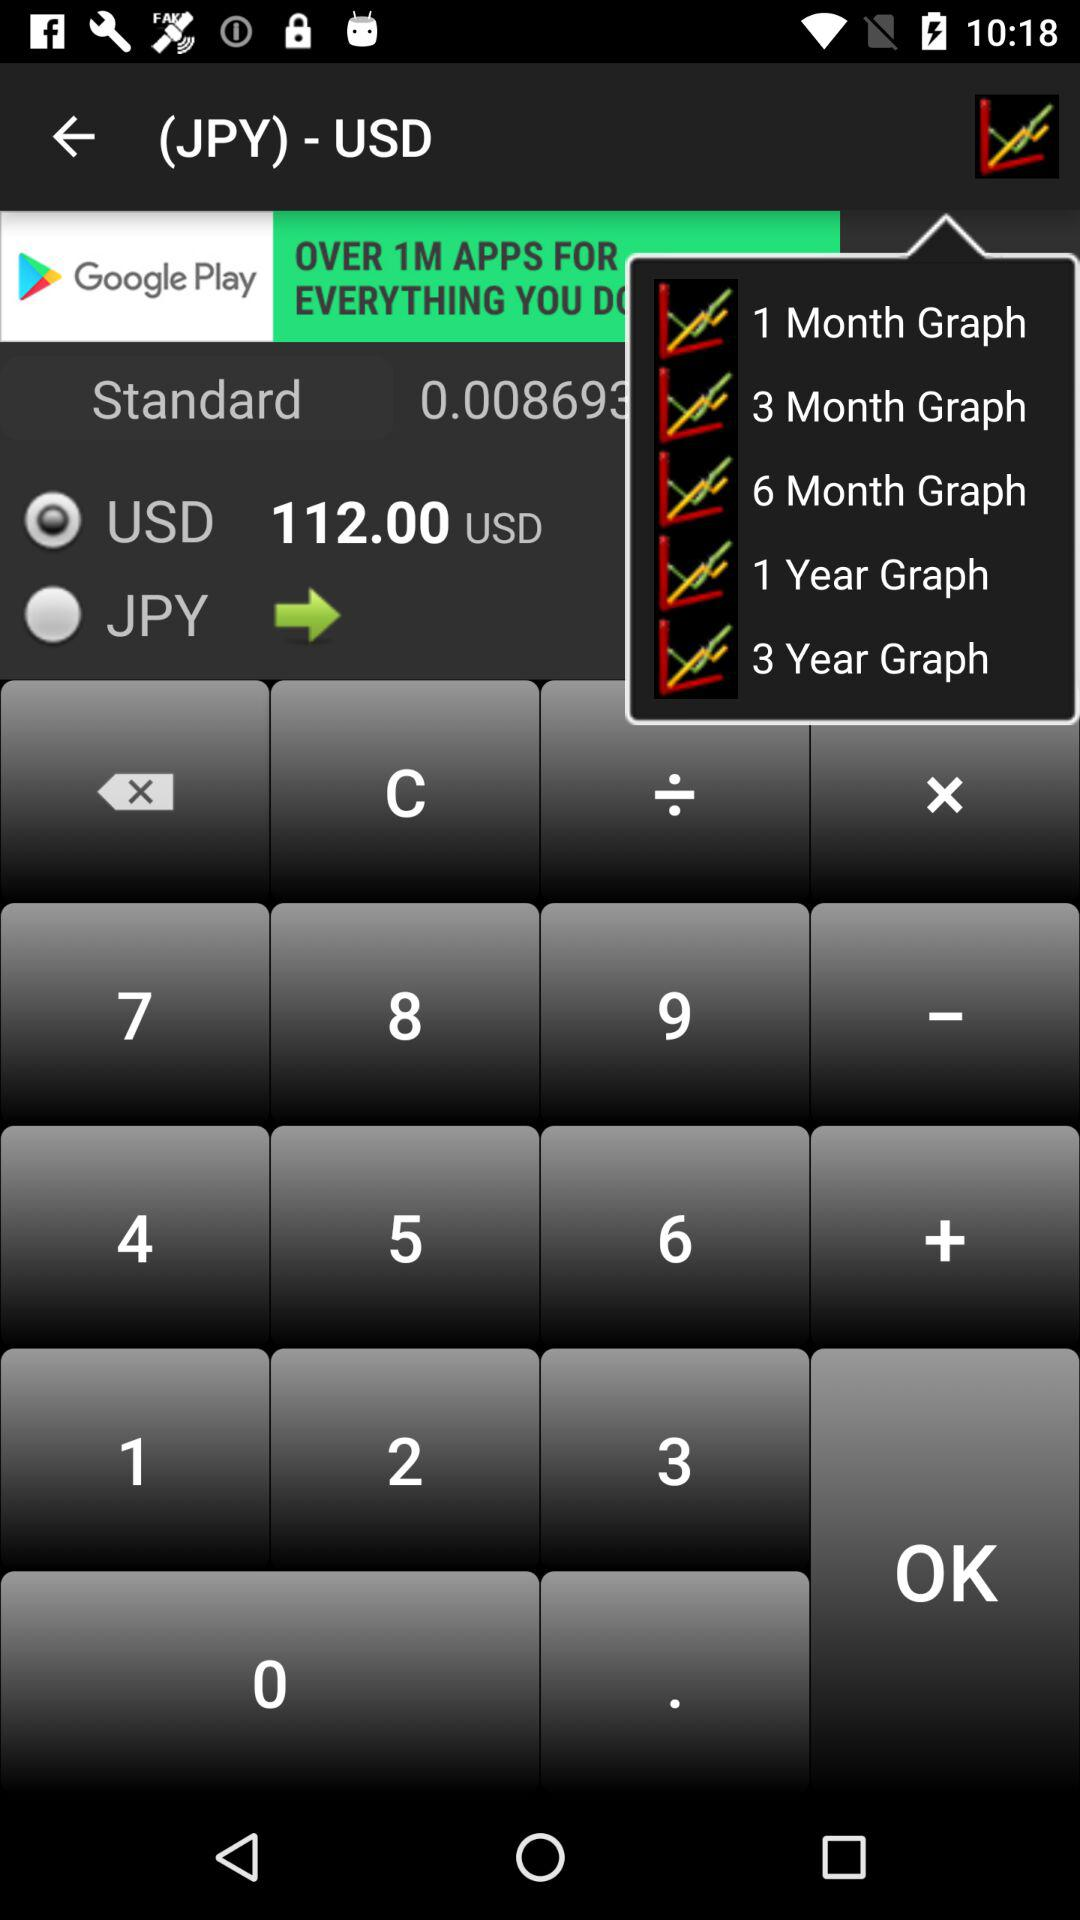How many more years are represented by the 3-year graph compared to the 1-year graph?
Answer the question using a single word or phrase. 2 